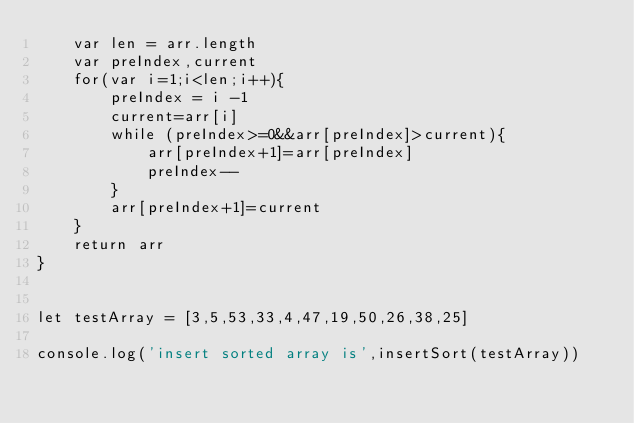Convert code to text. <code><loc_0><loc_0><loc_500><loc_500><_JavaScript_>    var len = arr.length
    var preIndex,current
    for(var i=1;i<len;i++){
        preIndex = i -1
        current=arr[i]
        while (preIndex>=0&&arr[preIndex]>current){
            arr[preIndex+1]=arr[preIndex]
            preIndex--
        }
        arr[preIndex+1]=current
    }
    return arr
}


let testArray = [3,5,53,33,4,47,19,50,26,38,25]

console.log('insert sorted array is',insertSort(testArray))</code> 